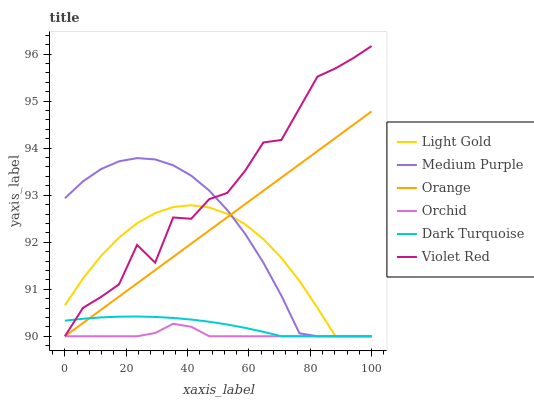Does Dark Turquoise have the minimum area under the curve?
Answer yes or no. No. Does Dark Turquoise have the maximum area under the curve?
Answer yes or no. No. Is Dark Turquoise the smoothest?
Answer yes or no. No. Is Dark Turquoise the roughest?
Answer yes or no. No. Does Dark Turquoise have the highest value?
Answer yes or no. No. 